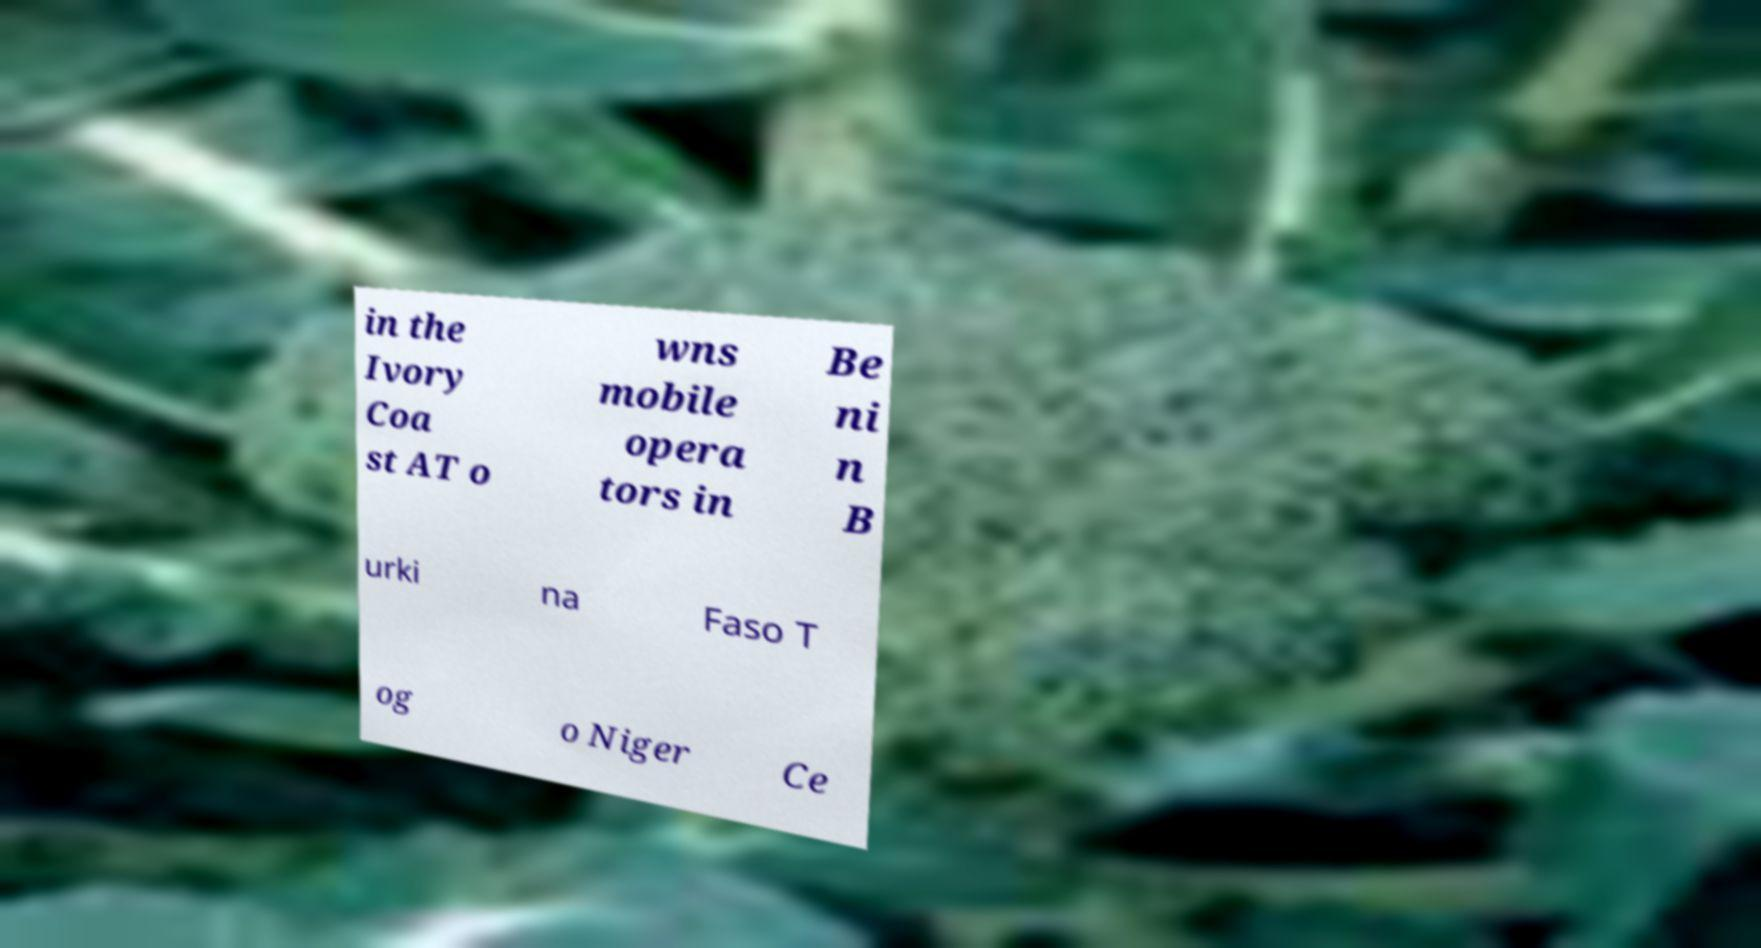Could you assist in decoding the text presented in this image and type it out clearly? in the Ivory Coa st AT o wns mobile opera tors in Be ni n B urki na Faso T og o Niger Ce 